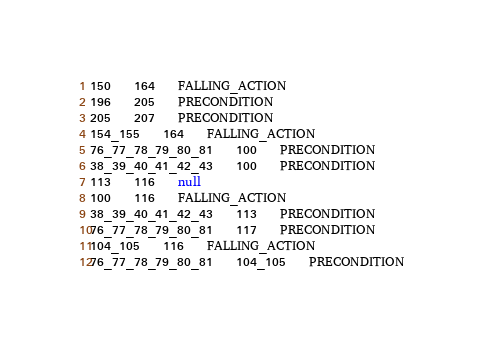<code> <loc_0><loc_0><loc_500><loc_500><_SQL_>150	164	FALLING_ACTION
196	205	PRECONDITION
205	207	PRECONDITION
154_155	164	FALLING_ACTION
76_77_78_79_80_81	100	PRECONDITION
38_39_40_41_42_43	100	PRECONDITION
113	116	null
100	116	FALLING_ACTION
38_39_40_41_42_43	113	PRECONDITION
76_77_78_79_80_81	117	PRECONDITION
104_105	116	FALLING_ACTION
76_77_78_79_80_81	104_105	PRECONDITION</code> 